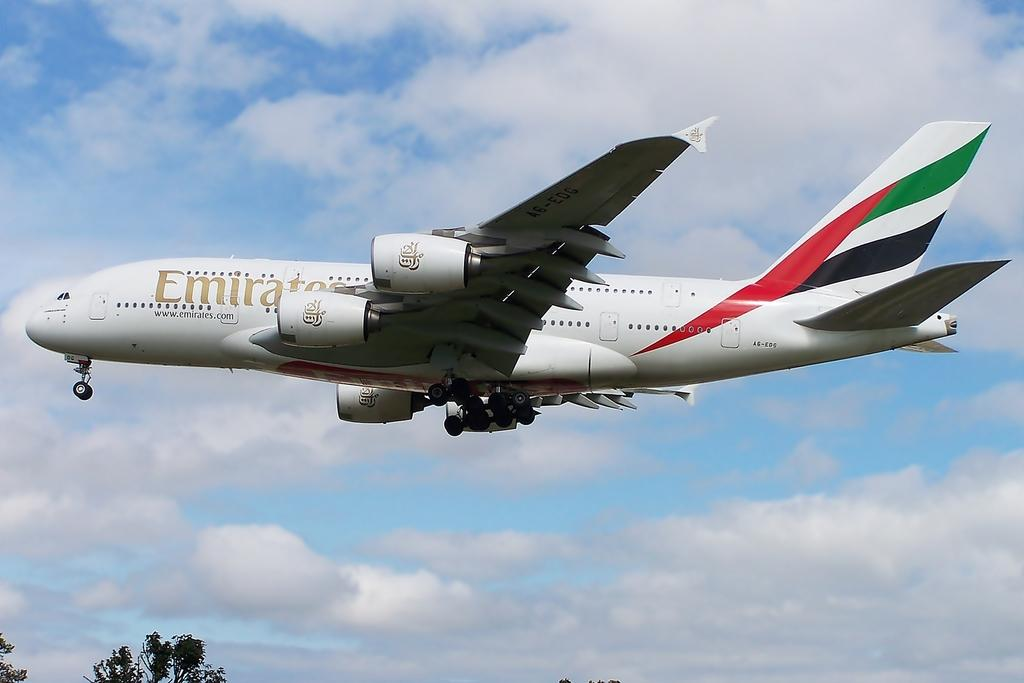What color is the airplane in the image? The airplane in the image is white. Where is the airplane located in the image? The airplane is in the air. What can be seen on the airplane? There is writing on the airplane. What is visible in the background of the image? There are trees, clouds, and the sky visible in the background of the image. How does the beginner use the rake in the image? There is no rake present in the image, so it is not possible to answer that question. 